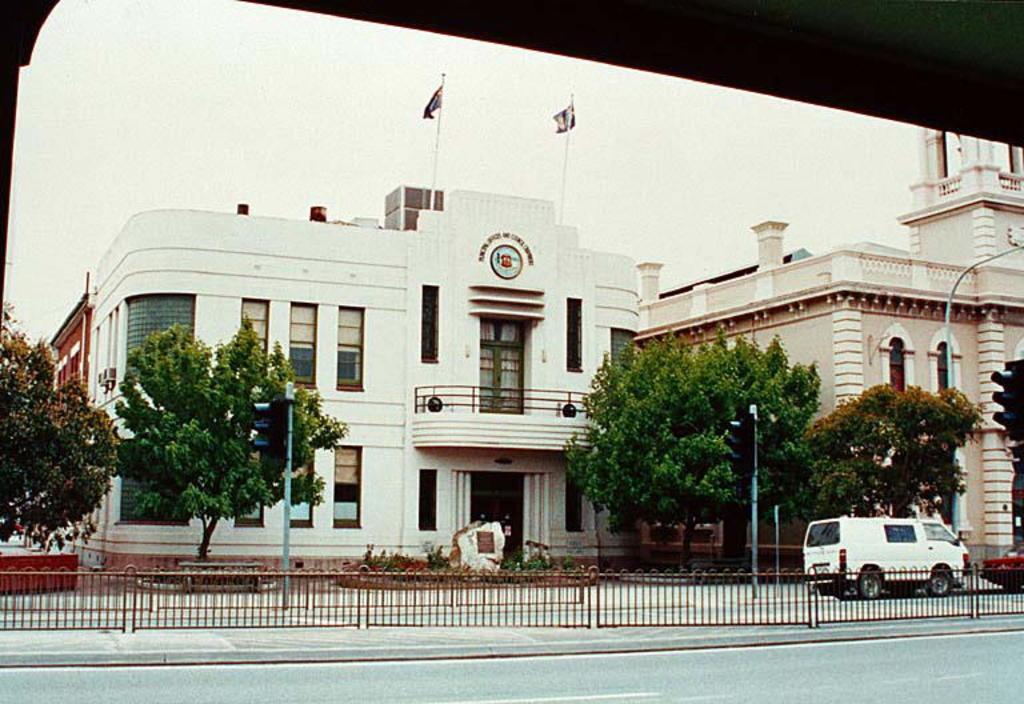Can you describe this image briefly? In the middle of the image we can see fencing. Behind the fencing there are some vehicles, poles and trees. Behind the trees there are some buildings. At the top of the image we can see two poles and flags. Behind them there is sky. In the top right corner of the image we can see roof. 